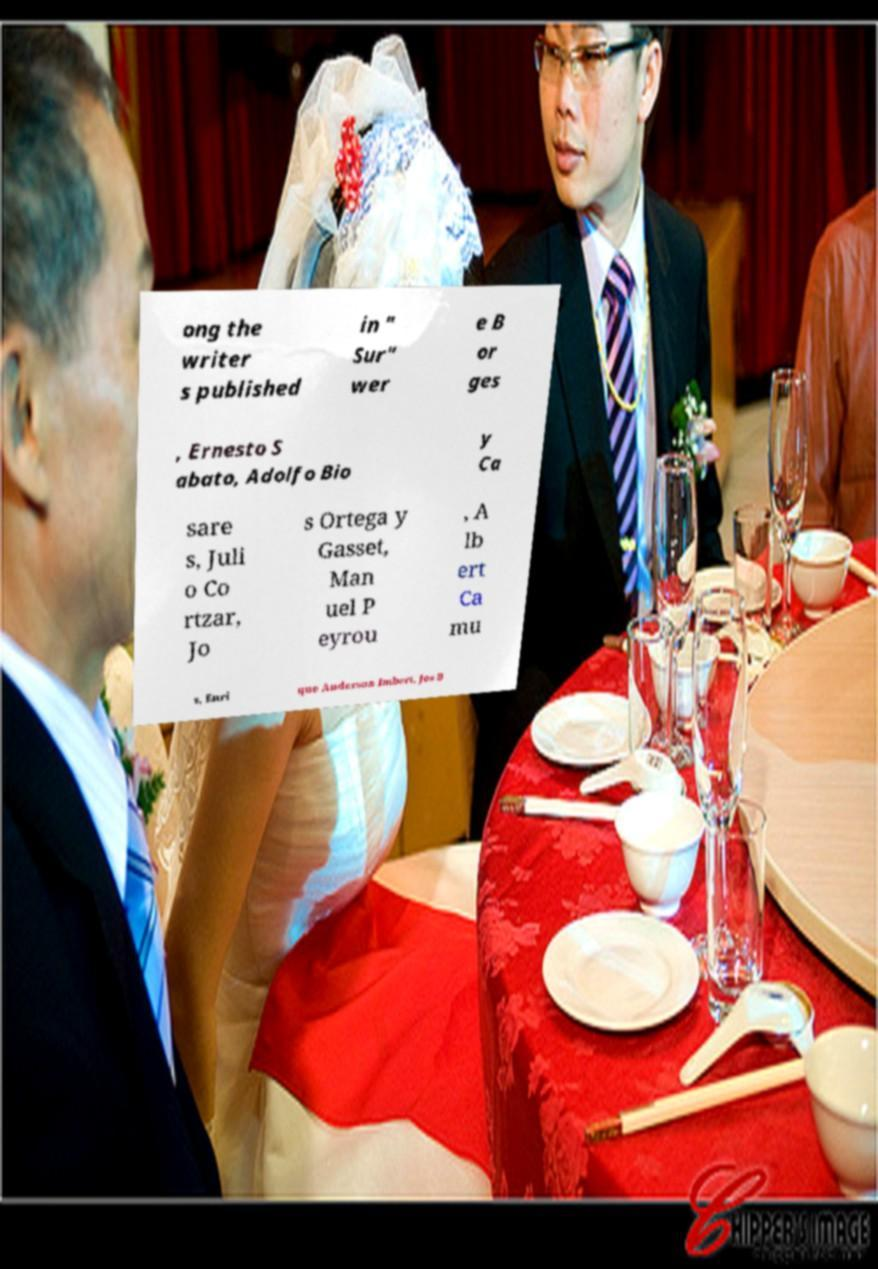Could you extract and type out the text from this image? ong the writer s published in " Sur" wer e B or ges , Ernesto S abato, Adolfo Bio y Ca sare s, Juli o Co rtzar, Jo s Ortega y Gasset, Man uel P eyrou , A lb ert Ca mu s, Enri que Anderson Imbert, Jos B 